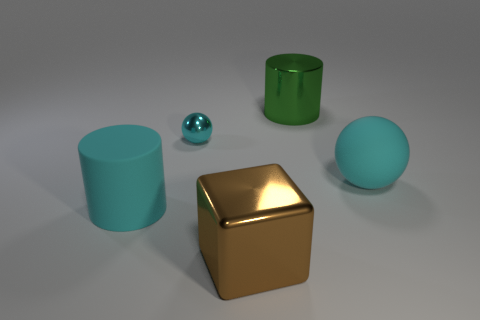How many other objects are there of the same color as the big shiny block?
Keep it short and to the point. 0. There is a metal object that is in front of the large matte cylinder; is its size the same as the cyan matte object that is to the left of the large green cylinder?
Offer a very short reply. Yes. Are there the same number of tiny balls that are in front of the tiny ball and cyan matte things that are behind the large cyan cylinder?
Ensure brevity in your answer.  No. Is there any other thing that has the same material as the green thing?
Provide a short and direct response. Yes. There is a green cylinder; does it have the same size as the cyan shiny thing that is to the left of the large green object?
Your response must be concise. No. There is a cylinder in front of the large cyan rubber thing right of the tiny shiny object; what is its material?
Provide a succinct answer. Rubber. Is the number of green metallic cylinders right of the large metallic cylinder the same as the number of small gray blocks?
Provide a short and direct response. Yes. What size is the thing that is in front of the large green shiny thing and on the right side of the metal cube?
Your answer should be very brief. Large. There is a big rubber thing to the right of the large cylinder in front of the green cylinder; what color is it?
Offer a very short reply. Cyan. How many green objects are either large matte spheres or metal objects?
Provide a succinct answer. 1. 